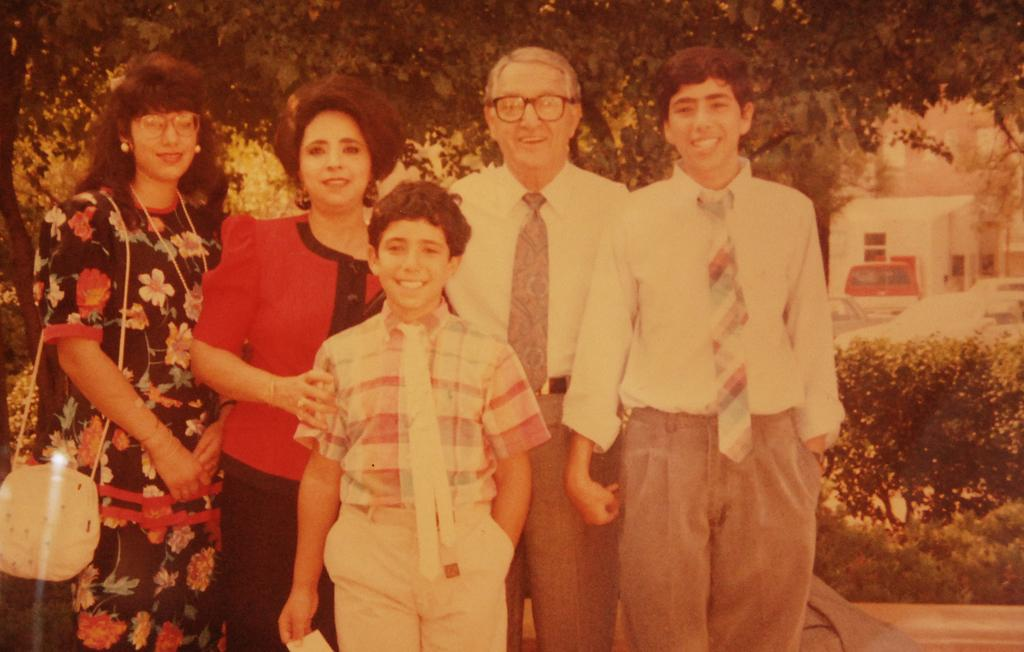What can be seen in the image involving human presence? There are people standing in the image. What type of natural elements are present in the image? There are trees in the image. What type of structure is visible in the image? There is a house in the image. What mode of transportation can be seen on the right side of the image? There is a car on the right side of the image. Can you see a note being passed between the people in the image? There is no note being passed between the people in the image. How many houses are visible in the image? There is only one house visible in the image. 